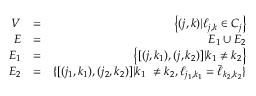<formula> <loc_0><loc_0><loc_500><loc_500>\begin{array} { r l r } { V } & { = } & { \left \{ ( j , k ) | \ell _ { j , k } \in C _ { j } \right \} } \\ { E } & { = } & { E _ { 1 } \cup E _ { 2 } } \\ { E _ { 1 } } & { = } & { \left \{ [ ( j , k _ { 1 } ) , ( j , k _ { 2 } ) ] | k _ { 1 } \neq k _ { 2 } \right \} } \\ { E _ { 2 } } & { = } & { \{ [ ( j _ { 1 } , k _ { 1 } ) , ( j _ { 2 } , k _ { 2 } ) ] | k _ { 1 } \ \neq k _ { 2 } , \ell _ { j _ { 1 } , k _ { 1 } } = \bar { \ell } _ { k _ { 2 } , k _ { 2 } } \} } \end{array}</formula> 